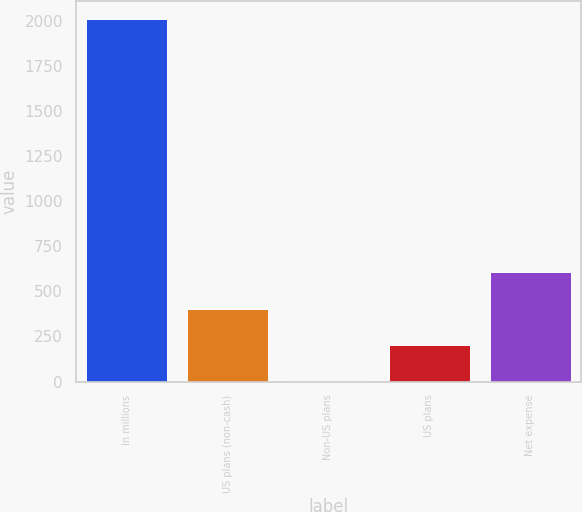<chart> <loc_0><loc_0><loc_500><loc_500><bar_chart><fcel>In millions<fcel>US plans (non-cash)<fcel>Non-US plans<fcel>US plans<fcel>Net expense<nl><fcel>2008<fcel>404.8<fcel>4<fcel>204.4<fcel>605.2<nl></chart> 